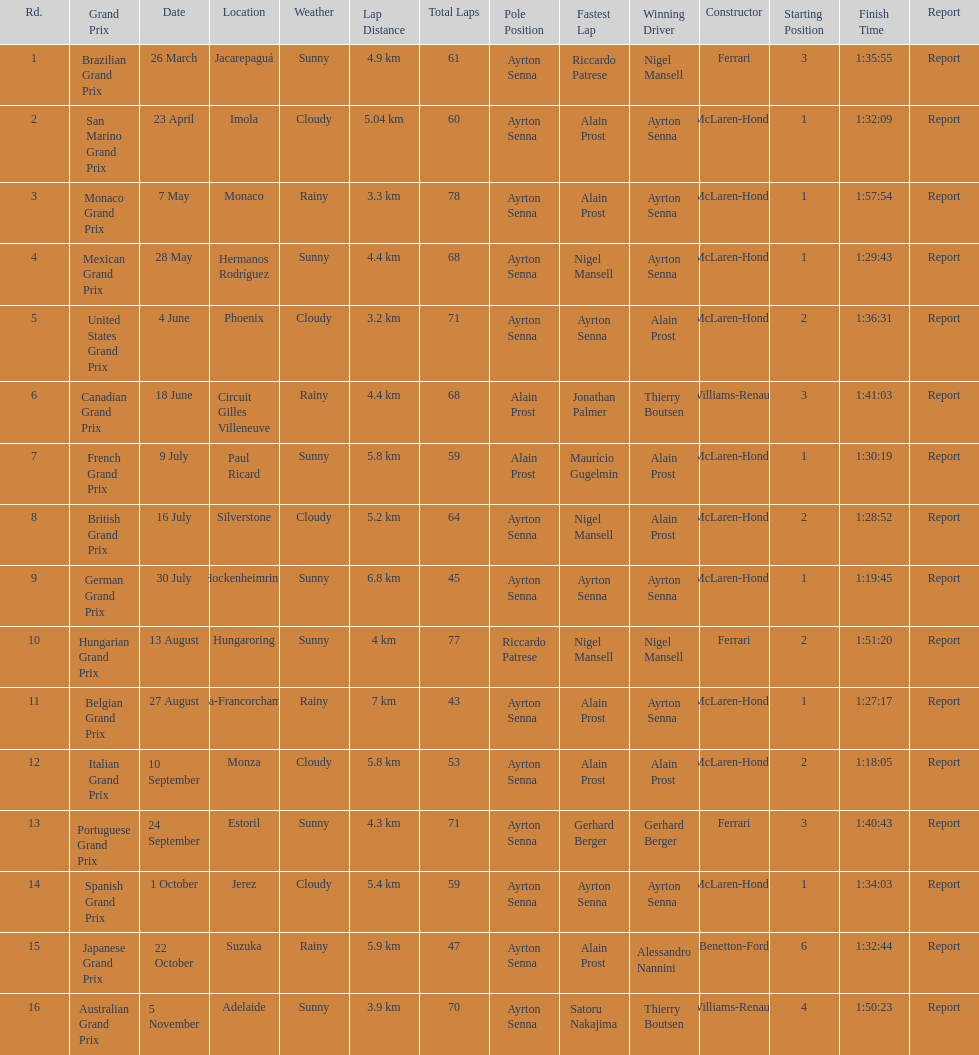Who had the fastest lap at the german grand prix? Ayrton Senna. 